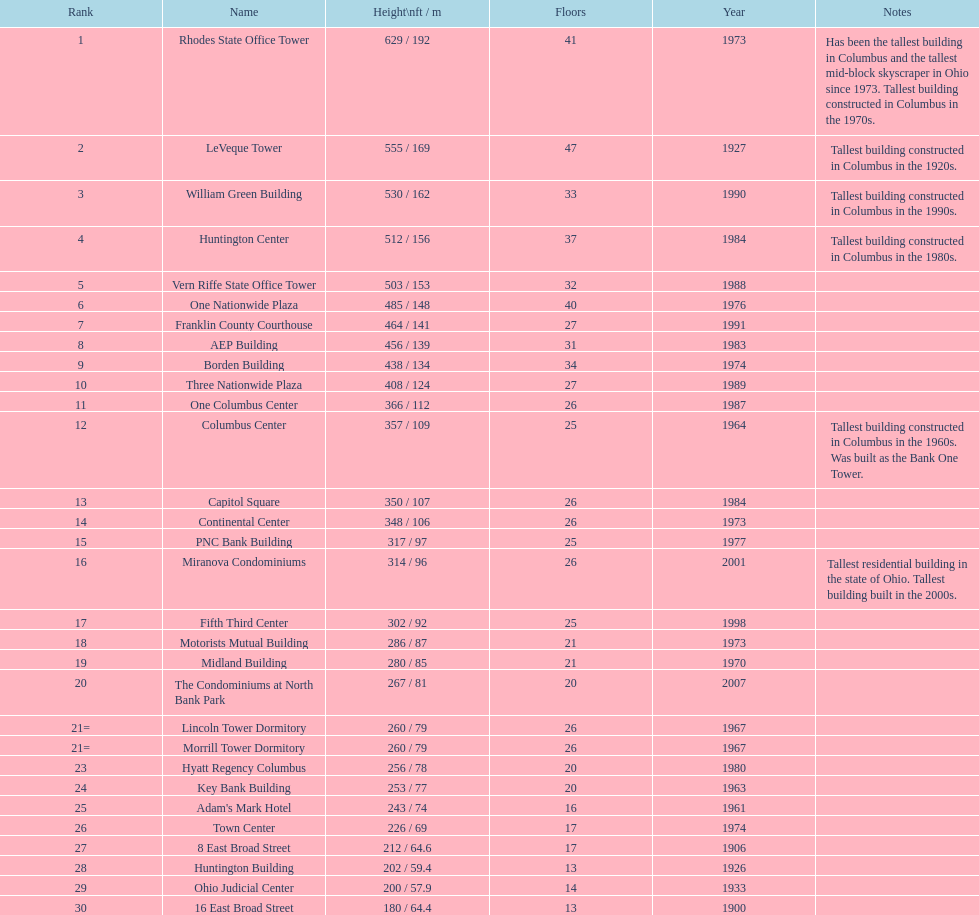What is the number of buildings under 200 ft? 1. 